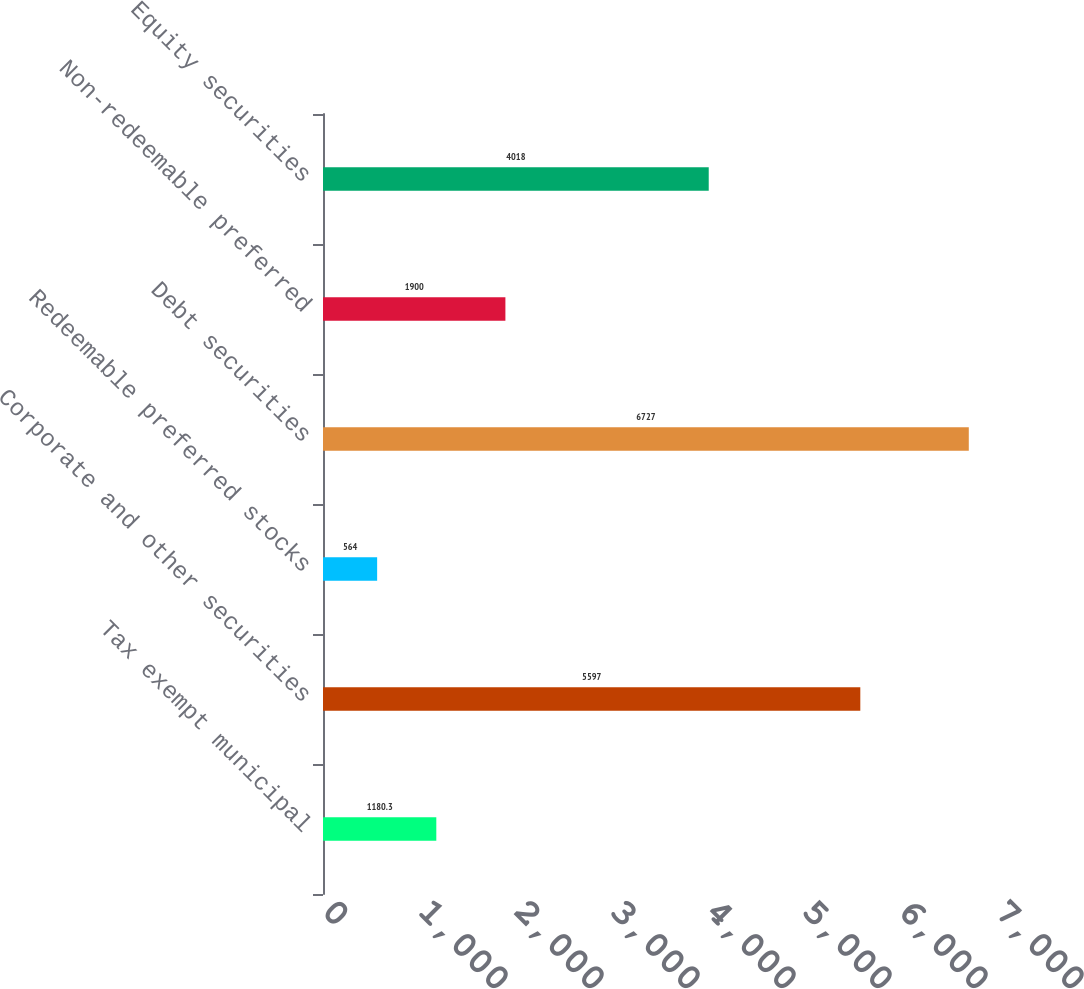<chart> <loc_0><loc_0><loc_500><loc_500><bar_chart><fcel>Tax exempt municipal<fcel>Corporate and other securities<fcel>Redeemable preferred stocks<fcel>Debt securities<fcel>Non-redeemable preferred<fcel>Equity securities<nl><fcel>1180.3<fcel>5597<fcel>564<fcel>6727<fcel>1900<fcel>4018<nl></chart> 